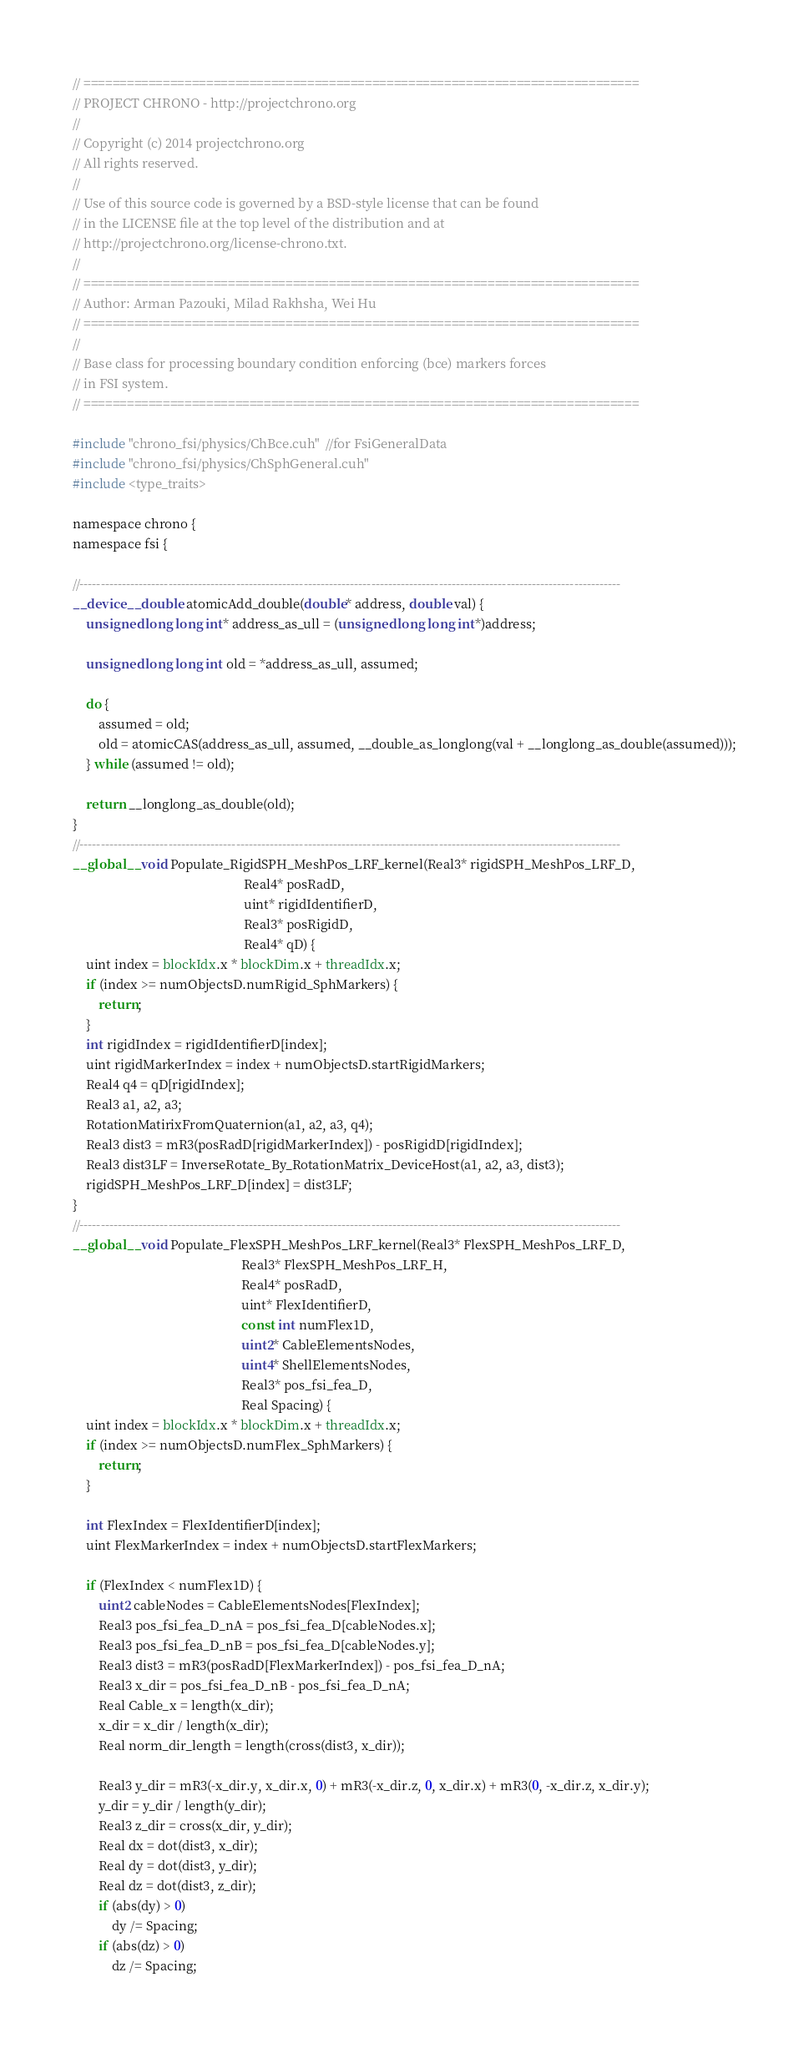Convert code to text. <code><loc_0><loc_0><loc_500><loc_500><_Cuda_>// =============================================================================
// PROJECT CHRONO - http://projectchrono.org
//
// Copyright (c) 2014 projectchrono.org
// All rights reserved.
//
// Use of this source code is governed by a BSD-style license that can be found
// in the LICENSE file at the top level of the distribution and at
// http://projectchrono.org/license-chrono.txt.
//
// =============================================================================
// Author: Arman Pazouki, Milad Rakhsha, Wei Hu
// =============================================================================
//
// Base class for processing boundary condition enforcing (bce) markers forces
// in FSI system.
// =============================================================================

#include "chrono_fsi/physics/ChBce.cuh"  //for FsiGeneralData
#include "chrono_fsi/physics/ChSphGeneral.cuh"
#include <type_traits>

namespace chrono {
namespace fsi {

//--------------------------------------------------------------------------------------------------------------------------------
__device__ double atomicAdd_double(double* address, double val) {
    unsigned long long int* address_as_ull = (unsigned long long int*)address;

    unsigned long long int old = *address_as_ull, assumed;

    do {
        assumed = old;
        old = atomicCAS(address_as_ull, assumed, __double_as_longlong(val + __longlong_as_double(assumed)));
    } while (assumed != old);

    return __longlong_as_double(old);
}
//--------------------------------------------------------------------------------------------------------------------------------
__global__ void Populate_RigidSPH_MeshPos_LRF_kernel(Real3* rigidSPH_MeshPos_LRF_D,
                                                     Real4* posRadD,
                                                     uint* rigidIdentifierD,
                                                     Real3* posRigidD,
                                                     Real4* qD) {
    uint index = blockIdx.x * blockDim.x + threadIdx.x;
    if (index >= numObjectsD.numRigid_SphMarkers) {
        return;
    }
    int rigidIndex = rigidIdentifierD[index];
    uint rigidMarkerIndex = index + numObjectsD.startRigidMarkers;
    Real4 q4 = qD[rigidIndex];
    Real3 a1, a2, a3;
    RotationMatirixFromQuaternion(a1, a2, a3, q4);
    Real3 dist3 = mR3(posRadD[rigidMarkerIndex]) - posRigidD[rigidIndex];
    Real3 dist3LF = InverseRotate_By_RotationMatrix_DeviceHost(a1, a2, a3, dist3);
    rigidSPH_MeshPos_LRF_D[index] = dist3LF;
}
//--------------------------------------------------------------------------------------------------------------------------------
__global__ void Populate_FlexSPH_MeshPos_LRF_kernel(Real3* FlexSPH_MeshPos_LRF_D,
                                                    Real3* FlexSPH_MeshPos_LRF_H,
                                                    Real4* posRadD,
                                                    uint* FlexIdentifierD,
                                                    const int numFlex1D,
                                                    uint2* CableElementsNodes,
                                                    uint4* ShellElementsNodes,
                                                    Real3* pos_fsi_fea_D,
                                                    Real Spacing) {
    uint index = blockIdx.x * blockDim.x + threadIdx.x;
    if (index >= numObjectsD.numFlex_SphMarkers) {
        return;
    }

    int FlexIndex = FlexIdentifierD[index];
    uint FlexMarkerIndex = index + numObjectsD.startFlexMarkers;

    if (FlexIndex < numFlex1D) {
        uint2 cableNodes = CableElementsNodes[FlexIndex];
        Real3 pos_fsi_fea_D_nA = pos_fsi_fea_D[cableNodes.x];
        Real3 pos_fsi_fea_D_nB = pos_fsi_fea_D[cableNodes.y];
        Real3 dist3 = mR3(posRadD[FlexMarkerIndex]) - pos_fsi_fea_D_nA;
        Real3 x_dir = pos_fsi_fea_D_nB - pos_fsi_fea_D_nA;
        Real Cable_x = length(x_dir);
        x_dir = x_dir / length(x_dir);
        Real norm_dir_length = length(cross(dist3, x_dir));

        Real3 y_dir = mR3(-x_dir.y, x_dir.x, 0) + mR3(-x_dir.z, 0, x_dir.x) + mR3(0, -x_dir.z, x_dir.y);
        y_dir = y_dir / length(y_dir);
        Real3 z_dir = cross(x_dir, y_dir);
        Real dx = dot(dist3, x_dir);
        Real dy = dot(dist3, y_dir);
        Real dz = dot(dist3, z_dir);
        if (abs(dy) > 0)
            dy /= Spacing;
        if (abs(dz) > 0)
            dz /= Spacing;
</code> 